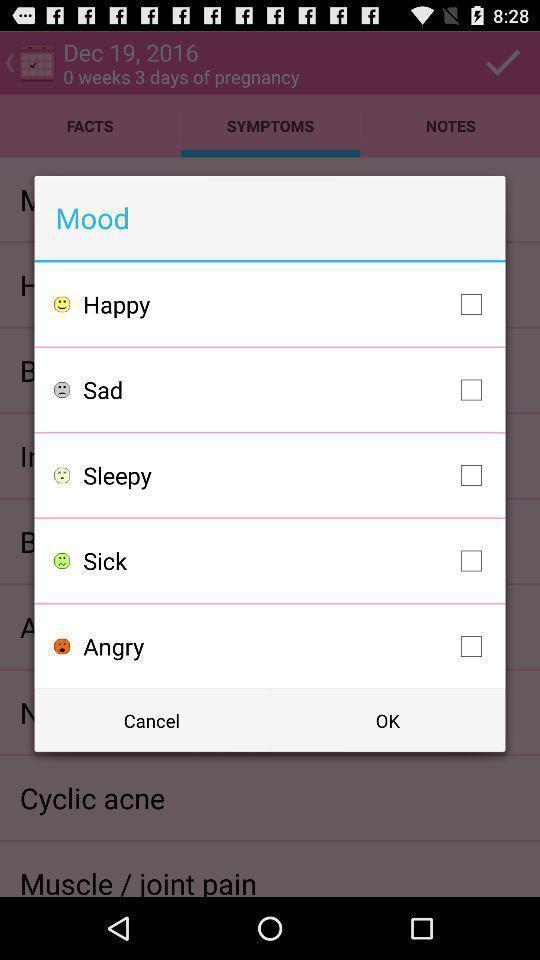What details can you identify in this image? Pop-up with list of different moods. 